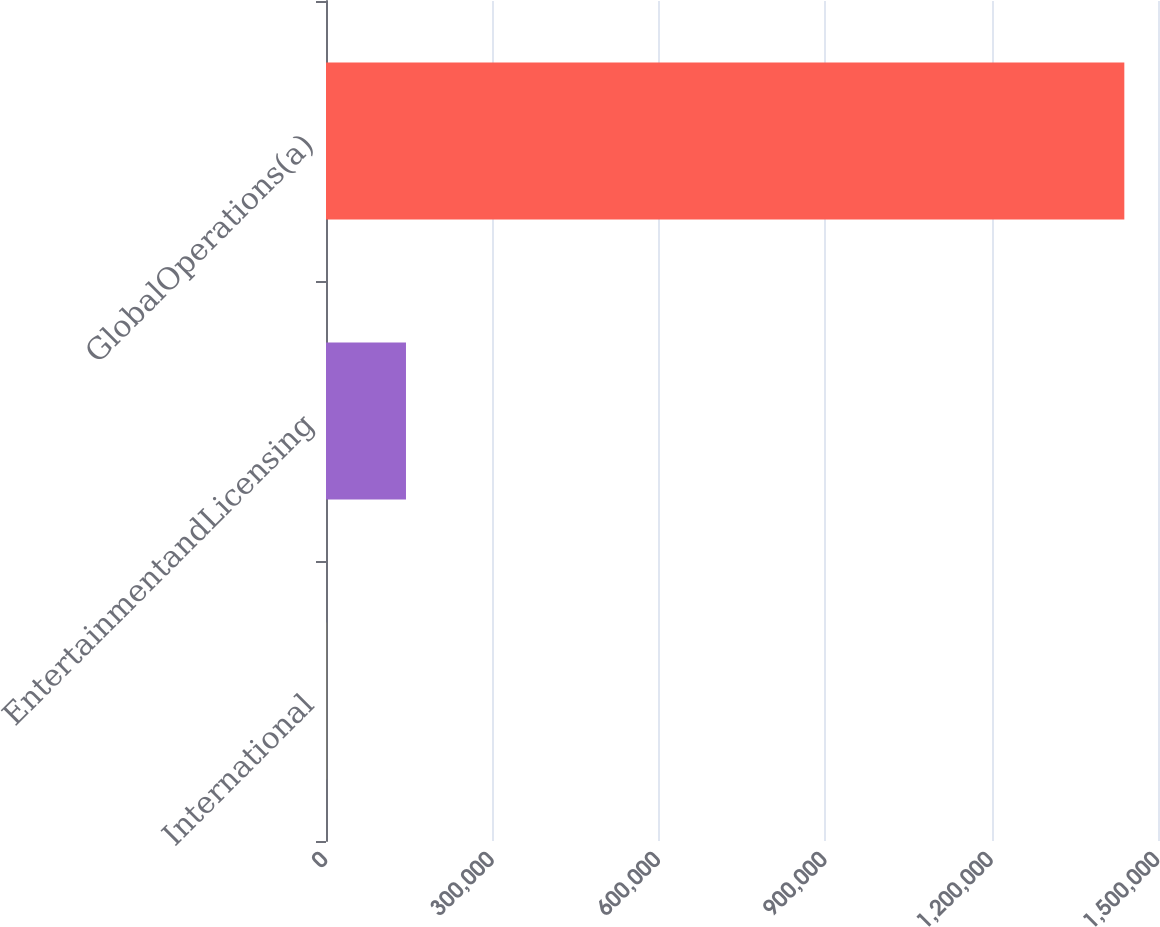Convert chart. <chart><loc_0><loc_0><loc_500><loc_500><bar_chart><fcel>International<fcel>EntertainmentandLicensing<fcel>GlobalOperations(a)<nl><fcel>290<fcel>144190<fcel>1.43929e+06<nl></chart> 